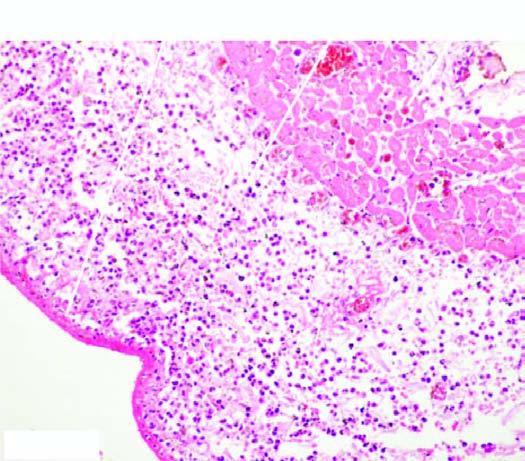what does the space between the layers of the pericardium contain?
Answer the question using a single word or phrase. Numerous inflammatory cells 